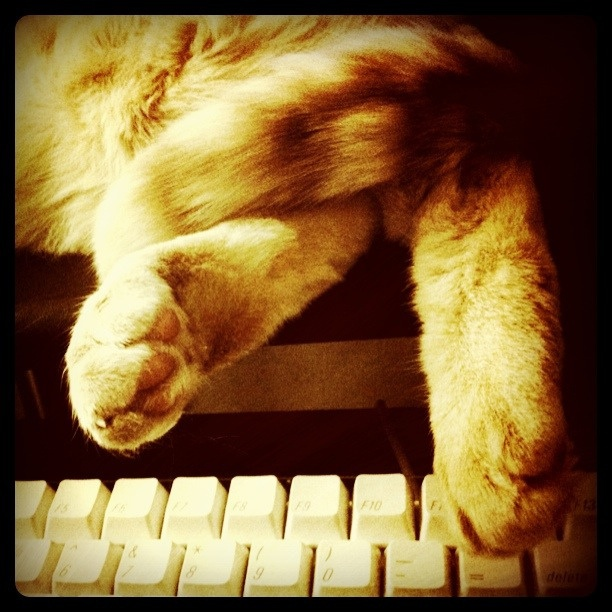Describe the objects in this image and their specific colors. I can see cat in black, brown, khaki, and maroon tones and keyboard in black, khaki, lightyellow, maroon, and tan tones in this image. 